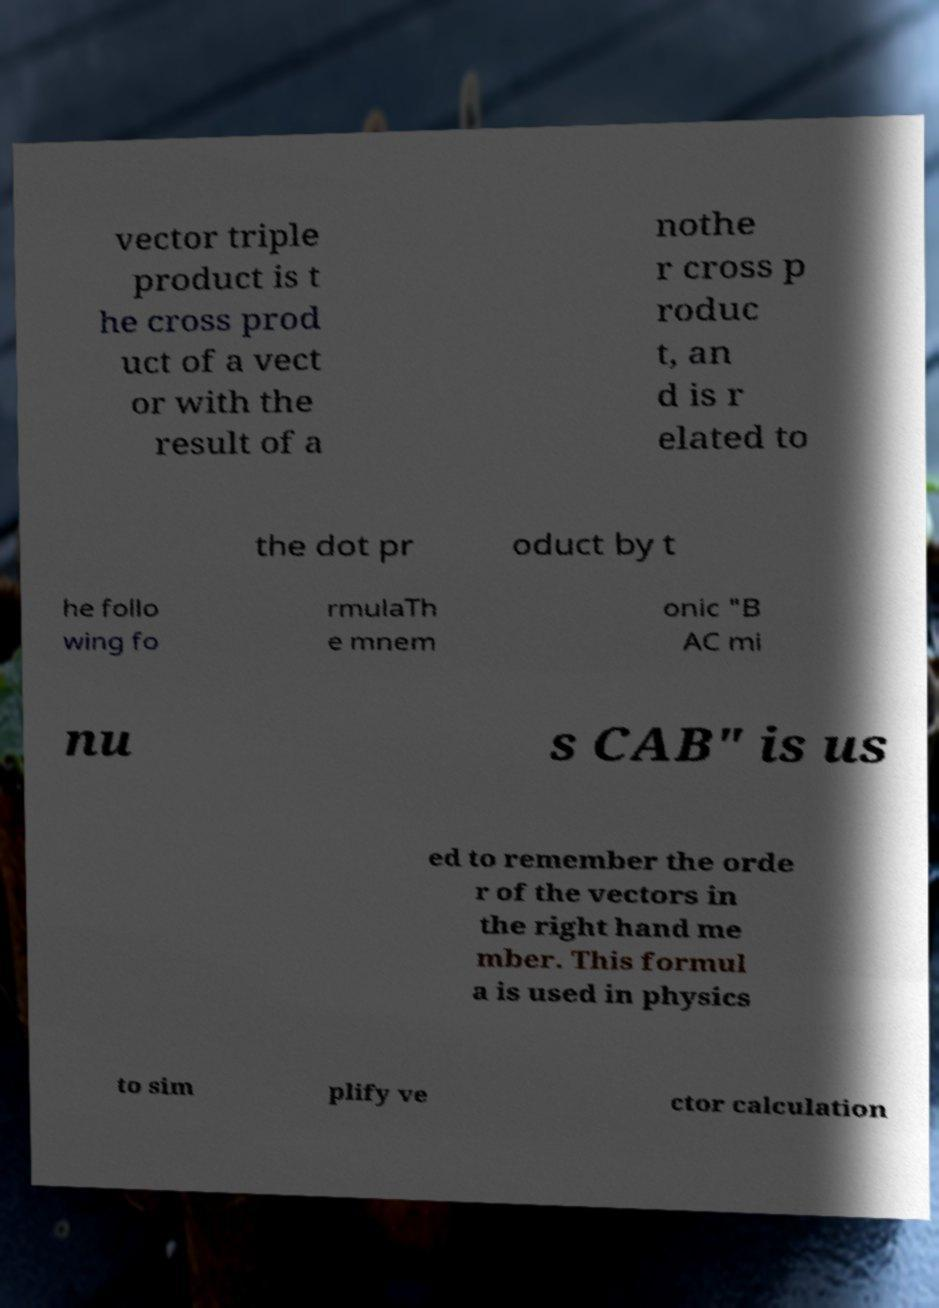Can you accurately transcribe the text from the provided image for me? vector triple product is t he cross prod uct of a vect or with the result of a nothe r cross p roduc t, an d is r elated to the dot pr oduct by t he follo wing fo rmulaTh e mnem onic "B AC mi nu s CAB" is us ed to remember the orde r of the vectors in the right hand me mber. This formul a is used in physics to sim plify ve ctor calculation 